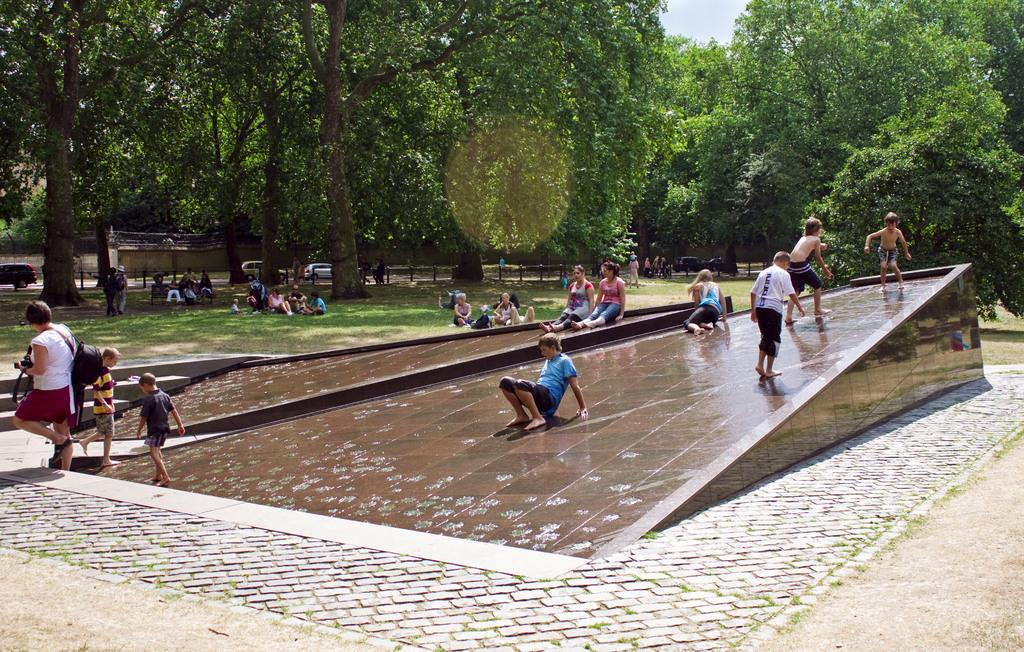How many people are in the image? There is a group of people in the image. What structures are present in the image? There are ramps in the image. What else can be seen on the road besides the ramps? Vehicles are visible on the road. What type of natural elements are present in the image? There are trees in the image. What is visible in the background of the image? The sky is visible in the background of the image. Can you tell me how many monkeys are sitting on the ramps in the image? There are no monkeys present in the image; it features a group of people, ramps, vehicles, trees, and the sky. What decision did the ants make in the image? There are no ants present in the image, so it is not possible to determine any decisions they might have made. 